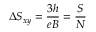Convert formula to latex. <formula><loc_0><loc_0><loc_500><loc_500>\Delta S _ { x y } = \frac { 3 h } { e B } = \frac { S } { N }</formula> 